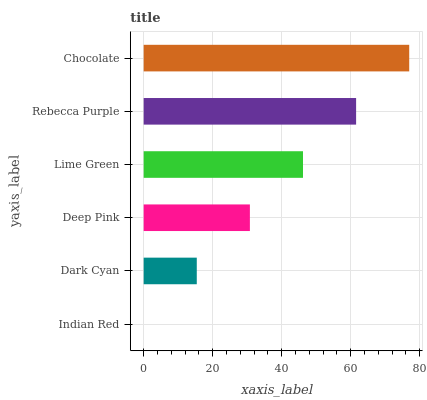Is Indian Red the minimum?
Answer yes or no. Yes. Is Chocolate the maximum?
Answer yes or no. Yes. Is Dark Cyan the minimum?
Answer yes or no. No. Is Dark Cyan the maximum?
Answer yes or no. No. Is Dark Cyan greater than Indian Red?
Answer yes or no. Yes. Is Indian Red less than Dark Cyan?
Answer yes or no. Yes. Is Indian Red greater than Dark Cyan?
Answer yes or no. No. Is Dark Cyan less than Indian Red?
Answer yes or no. No. Is Lime Green the high median?
Answer yes or no. Yes. Is Deep Pink the low median?
Answer yes or no. Yes. Is Dark Cyan the high median?
Answer yes or no. No. Is Indian Red the low median?
Answer yes or no. No. 